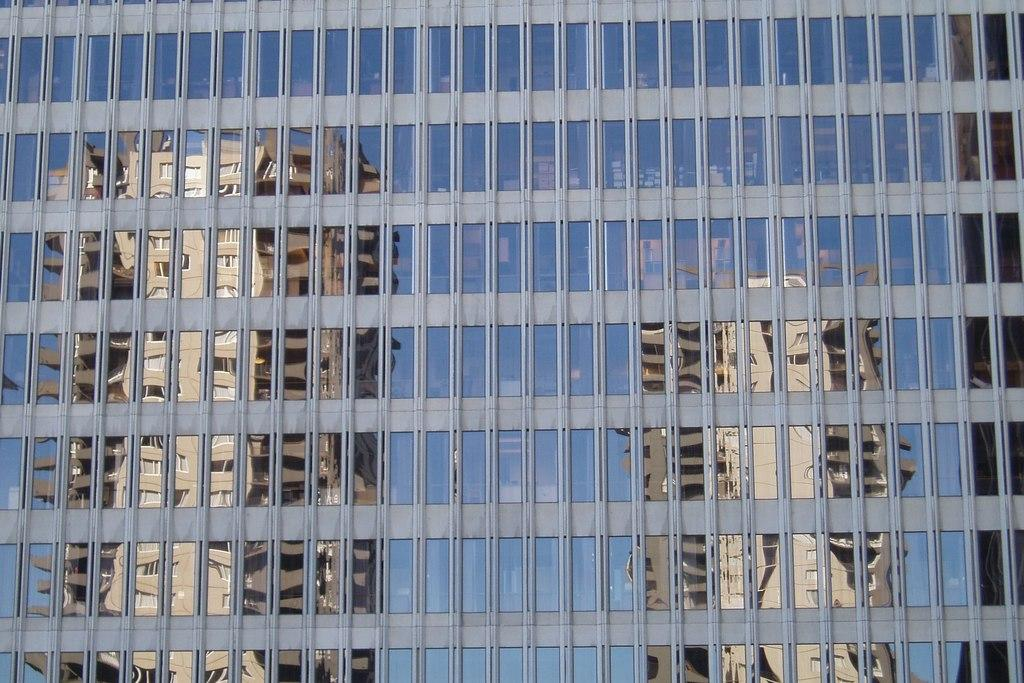What type of structure is depicted in the image? There is a building with glasses in the image. Can you describe the overall scene in the image? The image contains an image of buildings. What type of shape can be seen in the market area of the image? There is no market area present in the image, and therefore no shape can be observed in that context. 